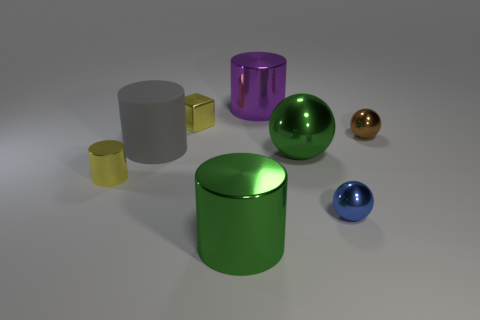Subtract 1 cylinders. How many cylinders are left? 3 Subtract all gray cylinders. How many cylinders are left? 3 Subtract all tiny metallic cylinders. How many cylinders are left? 3 Subtract all red cylinders. Subtract all red spheres. How many cylinders are left? 4 Add 2 brown objects. How many objects exist? 10 Subtract all balls. How many objects are left? 5 Subtract all big cyan spheres. Subtract all green spheres. How many objects are left? 7 Add 8 brown things. How many brown things are left? 9 Add 6 gray matte objects. How many gray matte objects exist? 7 Subtract 1 blue balls. How many objects are left? 7 